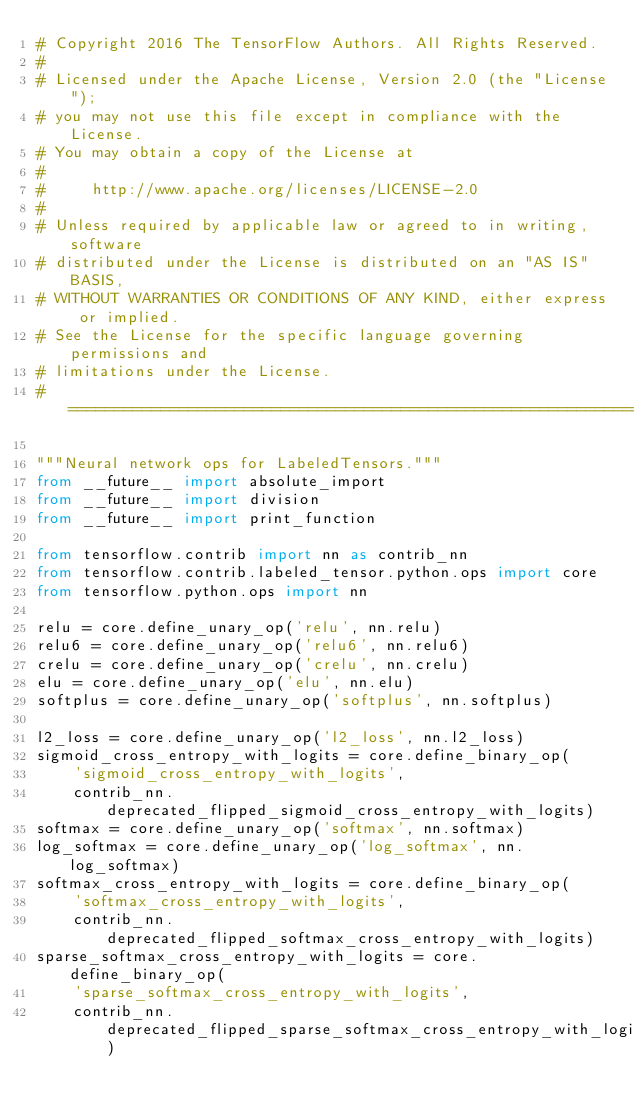Convert code to text. <code><loc_0><loc_0><loc_500><loc_500><_Python_># Copyright 2016 The TensorFlow Authors. All Rights Reserved.
#
# Licensed under the Apache License, Version 2.0 (the "License");
# you may not use this file except in compliance with the License.
# You may obtain a copy of the License at
#
#     http://www.apache.org/licenses/LICENSE-2.0
#
# Unless required by applicable law or agreed to in writing, software
# distributed under the License is distributed on an "AS IS" BASIS,
# WITHOUT WARRANTIES OR CONDITIONS OF ANY KIND, either express or implied.
# See the License for the specific language governing permissions and
# limitations under the License.
# ==============================================================================

"""Neural network ops for LabeledTensors."""
from __future__ import absolute_import
from __future__ import division
from __future__ import print_function

from tensorflow.contrib import nn as contrib_nn
from tensorflow.contrib.labeled_tensor.python.ops import core
from tensorflow.python.ops import nn

relu = core.define_unary_op('relu', nn.relu)
relu6 = core.define_unary_op('relu6', nn.relu6)
crelu = core.define_unary_op('crelu', nn.crelu)
elu = core.define_unary_op('elu', nn.elu)
softplus = core.define_unary_op('softplus', nn.softplus)

l2_loss = core.define_unary_op('l2_loss', nn.l2_loss)
sigmoid_cross_entropy_with_logits = core.define_binary_op(
    'sigmoid_cross_entropy_with_logits',
    contrib_nn.deprecated_flipped_sigmoid_cross_entropy_with_logits)
softmax = core.define_unary_op('softmax', nn.softmax)
log_softmax = core.define_unary_op('log_softmax', nn.log_softmax)
softmax_cross_entropy_with_logits = core.define_binary_op(
    'softmax_cross_entropy_with_logits',
    contrib_nn.deprecated_flipped_softmax_cross_entropy_with_logits)
sparse_softmax_cross_entropy_with_logits = core.define_binary_op(
    'sparse_softmax_cross_entropy_with_logits',
    contrib_nn.deprecated_flipped_sparse_softmax_cross_entropy_with_logits)
</code> 